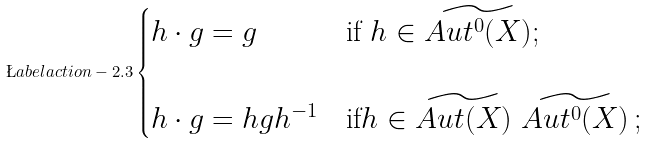<formula> <loc_0><loc_0><loc_500><loc_500>\L a b e l { a c t i o n - 2 . 3 } \begin{cases} h \cdot g = g & \text {if } h \in \widetilde { A u t ^ { 0 } ( X ) } ; \\ \\ h \cdot g = h g h ^ { - 1 } & \text {if} h \in \widetilde { A u t ( X ) } \ \widetilde { A u t ^ { 0 } ( X ) } \, ; \end{cases}</formula> 